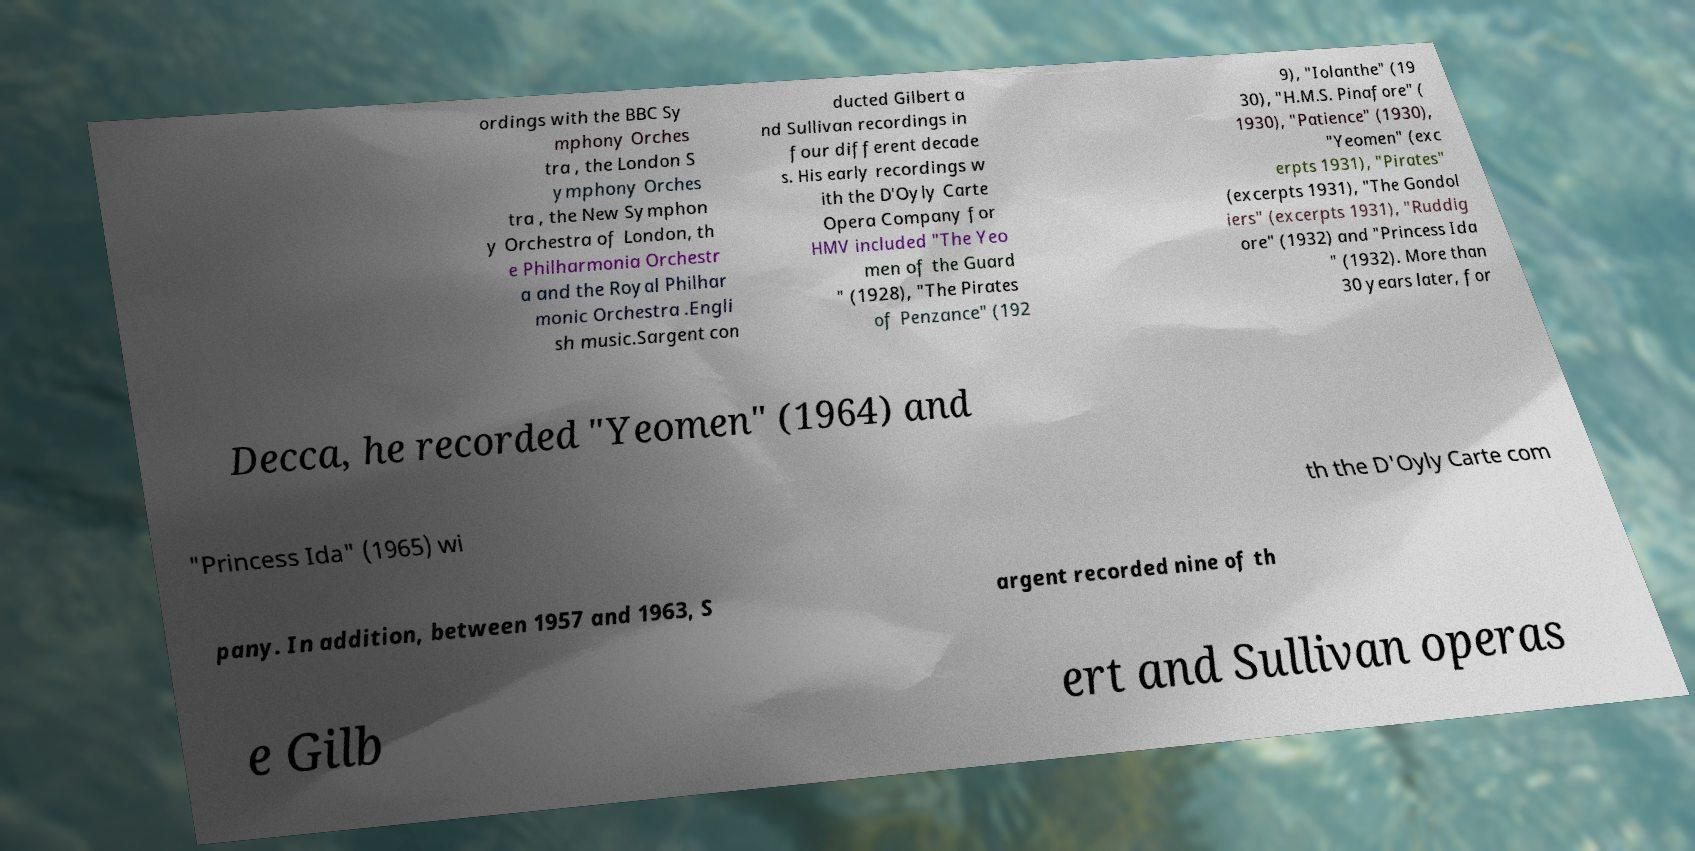Could you extract and type out the text from this image? ordings with the BBC Sy mphony Orches tra , the London S ymphony Orches tra , the New Symphon y Orchestra of London, th e Philharmonia Orchestr a and the Royal Philhar monic Orchestra .Engli sh music.Sargent con ducted Gilbert a nd Sullivan recordings in four different decade s. His early recordings w ith the D'Oyly Carte Opera Company for HMV included "The Yeo men of the Guard " (1928), "The Pirates of Penzance" (192 9), "Iolanthe" (19 30), "H.M.S. Pinafore" ( 1930), "Patience" (1930), "Yeomen" (exc erpts 1931), "Pirates" (excerpts 1931), "The Gondol iers" (excerpts 1931), "Ruddig ore" (1932) and "Princess Ida " (1932). More than 30 years later, for Decca, he recorded "Yeomen" (1964) and "Princess Ida" (1965) wi th the D'Oyly Carte com pany. In addition, between 1957 and 1963, S argent recorded nine of th e Gilb ert and Sullivan operas 